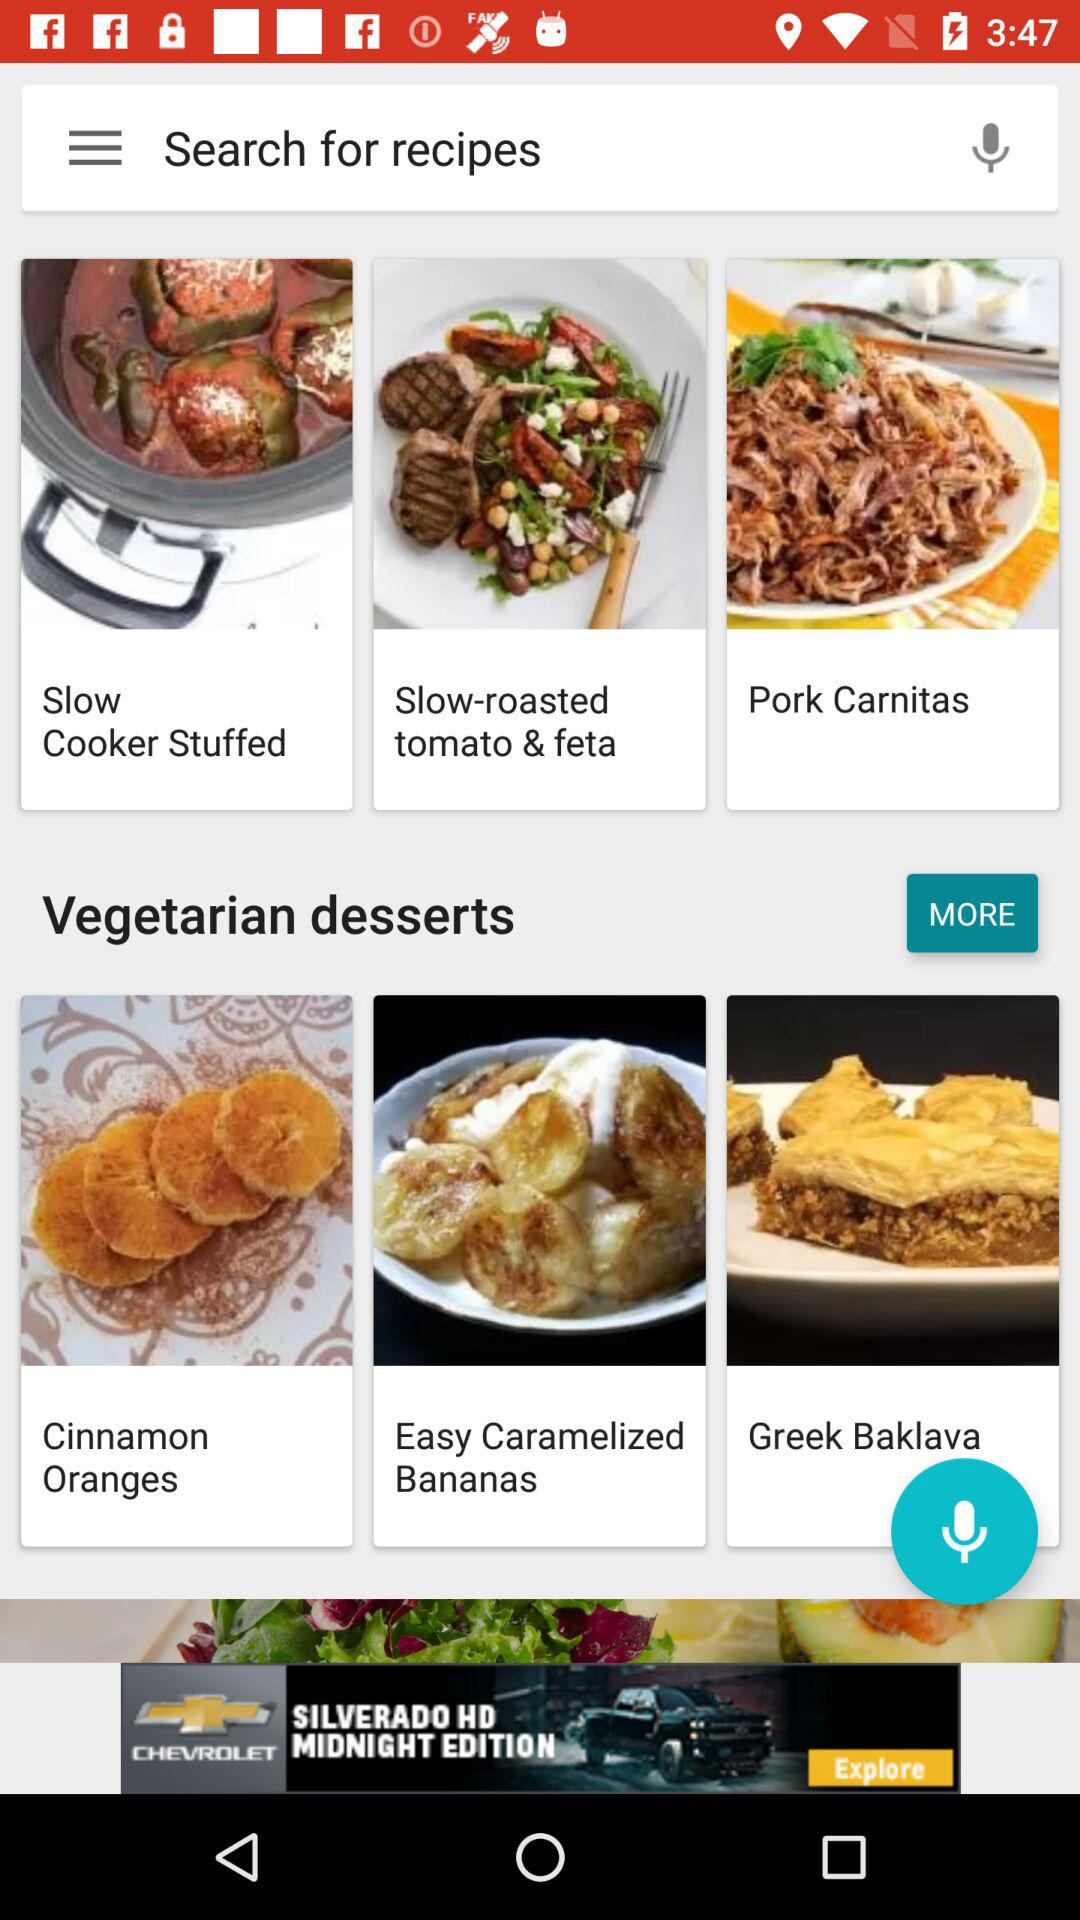How long does it take to prepare pork carnitas?
When the provided information is insufficient, respond with <no answer>. <no answer> 